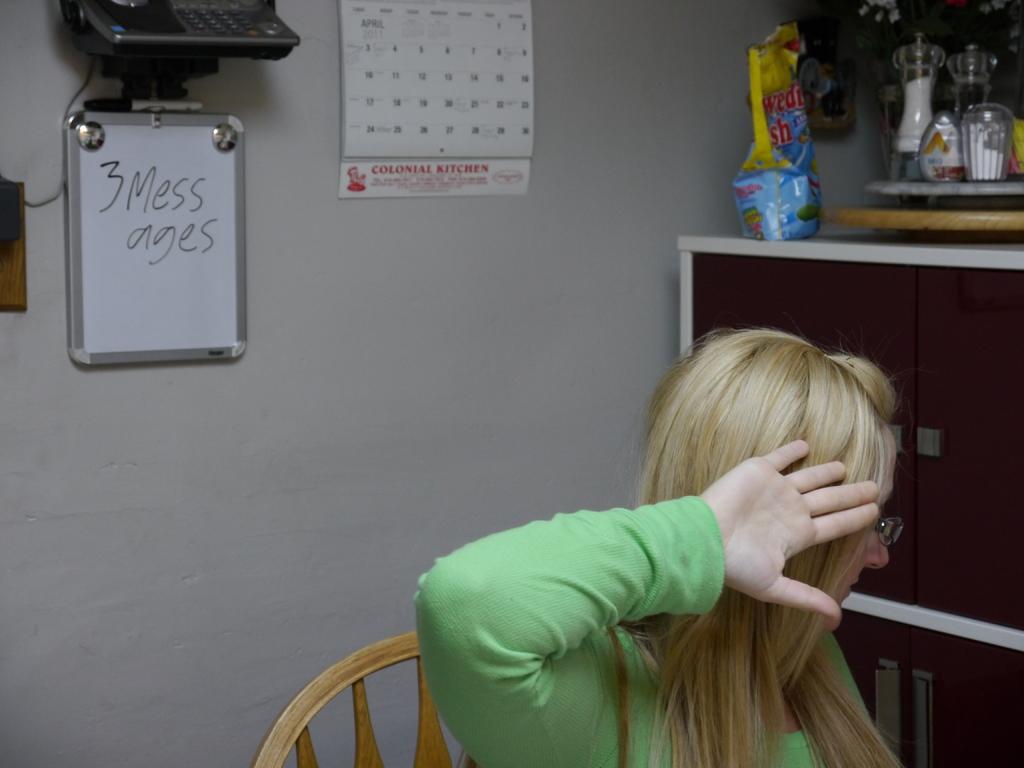Can you describe this image briefly? This image consists of calendar at the top, white board on the left side. There is a phone at the top. There are cupboard on the right side. On that there are glasses, cups. There is a woman at the bottom. She is sitting on a chair. 